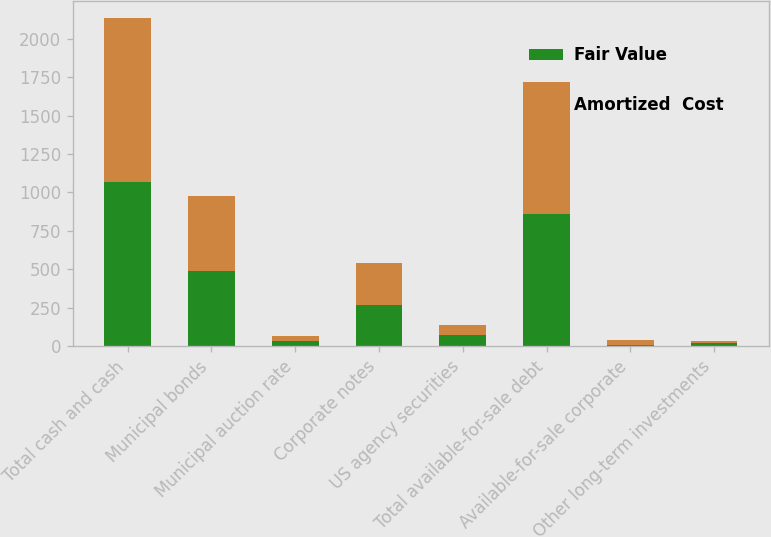Convert chart. <chart><loc_0><loc_0><loc_500><loc_500><stacked_bar_chart><ecel><fcel>Total cash and cash<fcel>Municipal bonds<fcel>Municipal auction rate<fcel>Corporate notes<fcel>US agency securities<fcel>Total available-for-sale debt<fcel>Available-for-sale corporate<fcel>Other long-term investments<nl><fcel>Fair Value<fcel>1069<fcel>489<fcel>33<fcel>269<fcel>69<fcel>860<fcel>5<fcel>17<nl><fcel>Amortized  Cost<fcel>1069<fcel>489<fcel>33<fcel>269<fcel>69<fcel>860<fcel>33<fcel>17<nl></chart> 